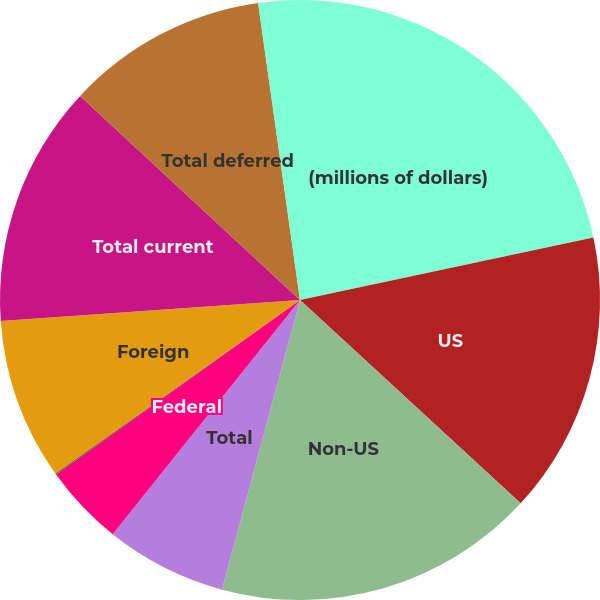Convert chart. <chart><loc_0><loc_0><loc_500><loc_500><pie_chart><fcel>(millions of dollars)<fcel>US<fcel>Non-US<fcel>Total<fcel>Federal<fcel>State<fcel>Foreign<fcel>Total current<fcel>Total deferred<fcel>Total provision for income<nl><fcel>21.66%<fcel>15.18%<fcel>17.34%<fcel>6.54%<fcel>4.38%<fcel>0.07%<fcel>8.7%<fcel>13.02%<fcel>10.86%<fcel>2.23%<nl></chart> 